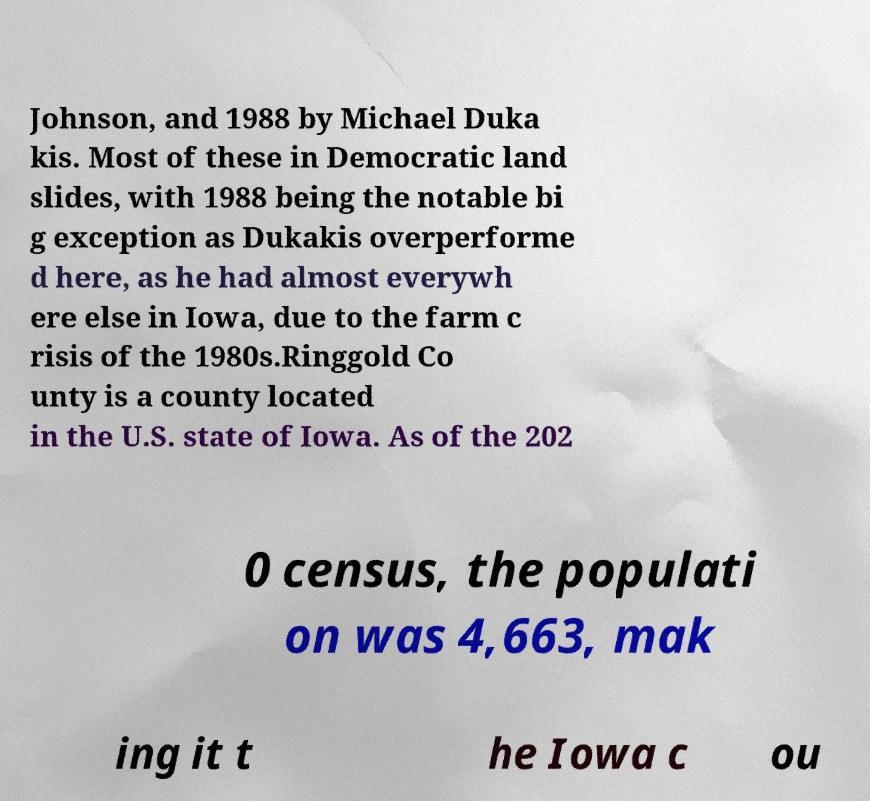Can you accurately transcribe the text from the provided image for me? Johnson, and 1988 by Michael Duka kis. Most of these in Democratic land slides, with 1988 being the notable bi g exception as Dukakis overperforme d here, as he had almost everywh ere else in Iowa, due to the farm c risis of the 1980s.Ringgold Co unty is a county located in the U.S. state of Iowa. As of the 202 0 census, the populati on was 4,663, mak ing it t he Iowa c ou 